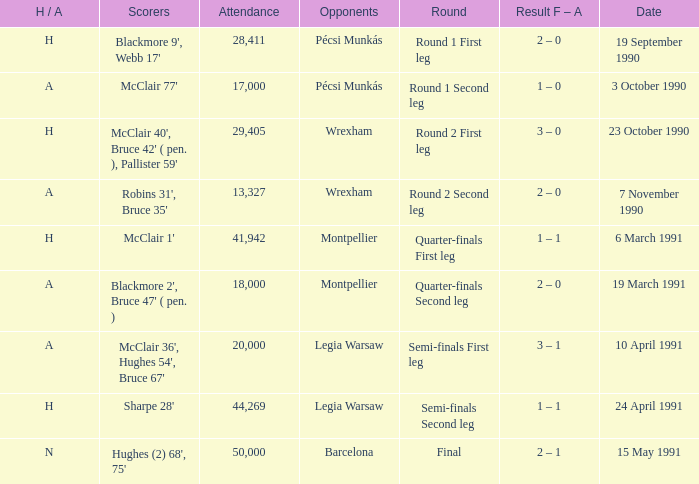What is the opponent name when the H/A is h with more than 28,411 in attendance and Sharpe 28' is the scorer? Legia Warsaw. 